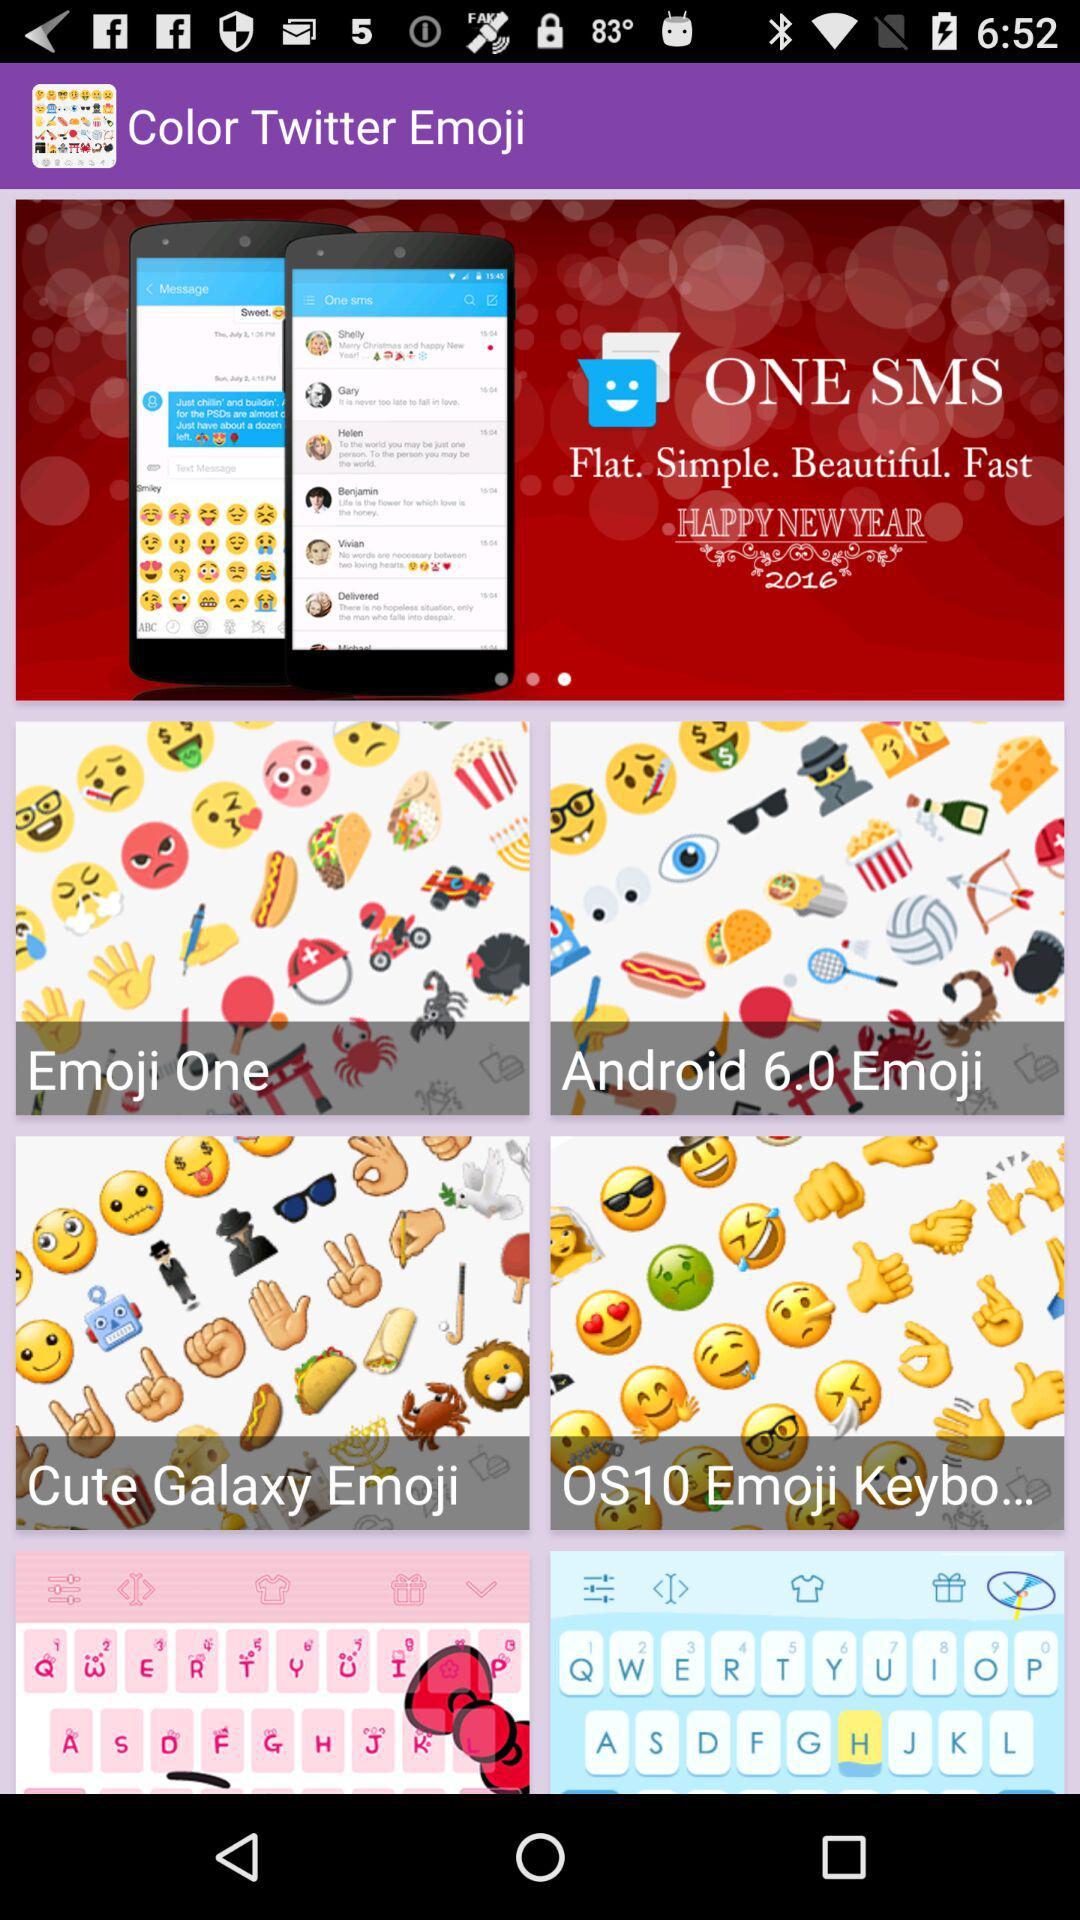What is the application name? The application name is "Color Twitter Emoji". 